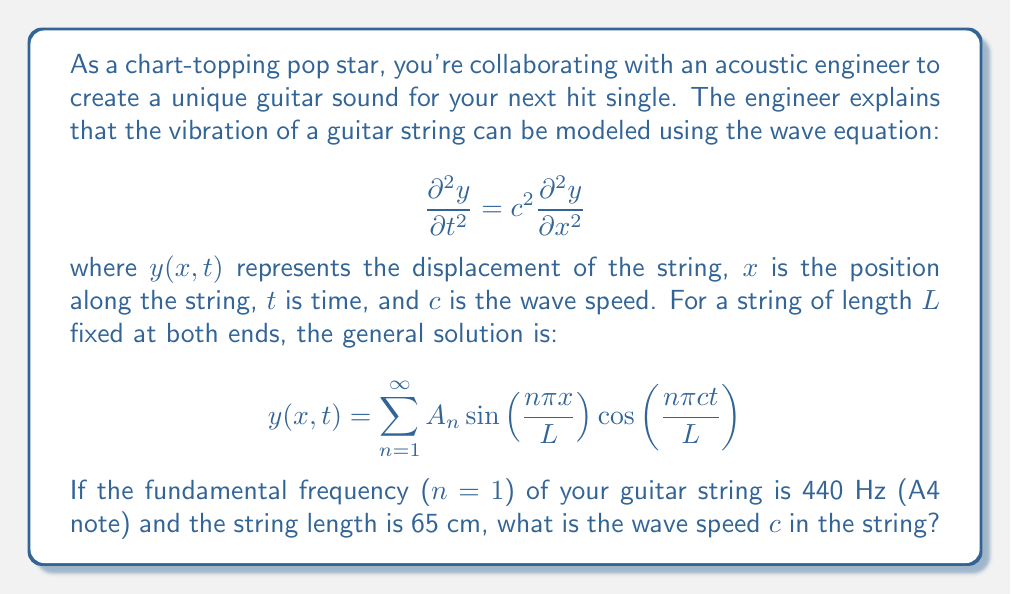Help me with this question. Let's approach this step-by-step:

1) The general solution gives us the form of the standing waves on the string. Each term in the sum represents a mode of vibration, with $n=1$ being the fundamental mode.

2) The frequency of each mode is given by:

   $$f_n = \frac{nc}{2L}$$

   where $f_n$ is the frequency of the nth mode, $c$ is the wave speed, and $L$ is the length of the string.

3) We're told that the fundamental frequency (n=1) is 440 Hz, so:

   $$440 = \frac{1c}{2L}$$

4) We're also given that the length of the string $L = 65$ cm $= 0.65$ m.

5) Substituting this into our equation:

   $$440 = \frac{c}{2(0.65)}$$

6) Now we can solve for $c$:

   $$c = 440 * 2 * 0.65 = 572 \text{ m/s}$$

Thus, the wave speed in the string is 572 m/s.
Answer: $c = 572 \text{ m/s}$ 